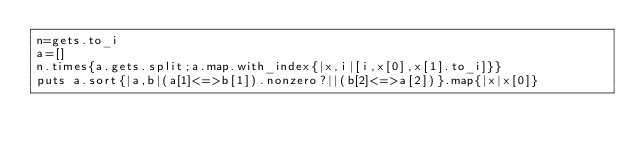Convert code to text. <code><loc_0><loc_0><loc_500><loc_500><_Ruby_>n=gets.to_i
a=[]
n.times{a.gets.split;a.map.with_index{|x,i|[i,x[0],x[1].to_i]}}
puts a.sort{|a,b|(a[1]<=>b[1]).nonzero?||(b[2]<=>a[2])}.map{|x|x[0]}</code> 